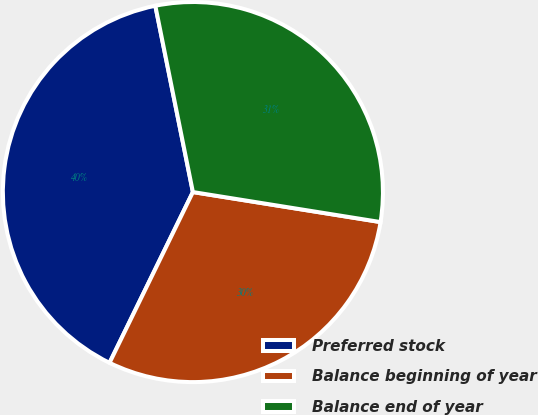<chart> <loc_0><loc_0><loc_500><loc_500><pie_chart><fcel>Preferred stock<fcel>Balance beginning of year<fcel>Balance end of year<nl><fcel>39.6%<fcel>29.7%<fcel>30.69%<nl></chart> 